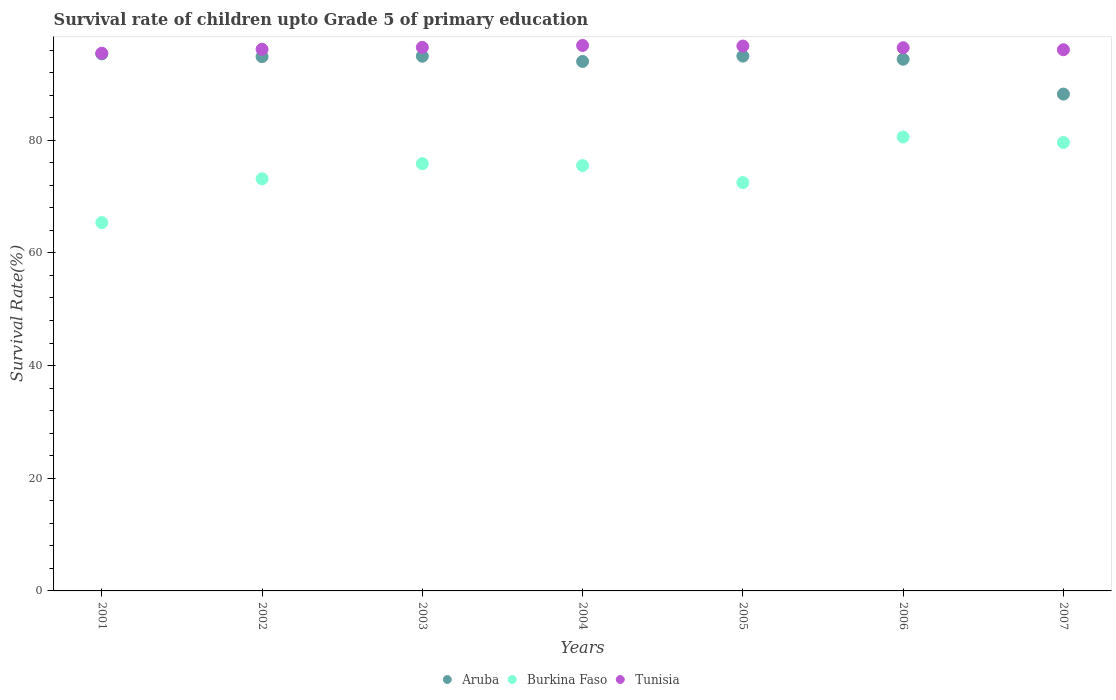How many different coloured dotlines are there?
Your response must be concise. 3. What is the survival rate of children in Aruba in 2005?
Offer a terse response. 94.94. Across all years, what is the maximum survival rate of children in Aruba?
Offer a terse response. 95.33. Across all years, what is the minimum survival rate of children in Aruba?
Make the answer very short. 88.2. What is the total survival rate of children in Aruba in the graph?
Your answer should be very brief. 656.62. What is the difference between the survival rate of children in Aruba in 2002 and that in 2005?
Provide a short and direct response. -0.09. What is the difference between the survival rate of children in Burkina Faso in 2006 and the survival rate of children in Tunisia in 2004?
Make the answer very short. -16.26. What is the average survival rate of children in Burkina Faso per year?
Keep it short and to the point. 74.66. In the year 2003, what is the difference between the survival rate of children in Aruba and survival rate of children in Tunisia?
Your response must be concise. -1.57. In how many years, is the survival rate of children in Tunisia greater than 72 %?
Provide a short and direct response. 7. What is the ratio of the survival rate of children in Tunisia in 2001 to that in 2002?
Provide a succinct answer. 0.99. Is the survival rate of children in Burkina Faso in 2001 less than that in 2007?
Keep it short and to the point. Yes. Is the difference between the survival rate of children in Aruba in 2001 and 2007 greater than the difference between the survival rate of children in Tunisia in 2001 and 2007?
Offer a very short reply. Yes. What is the difference between the highest and the second highest survival rate of children in Tunisia?
Your answer should be compact. 0.11. What is the difference between the highest and the lowest survival rate of children in Aruba?
Make the answer very short. 7.13. In how many years, is the survival rate of children in Burkina Faso greater than the average survival rate of children in Burkina Faso taken over all years?
Provide a short and direct response. 4. Is it the case that in every year, the sum of the survival rate of children in Burkina Faso and survival rate of children in Aruba  is greater than the survival rate of children in Tunisia?
Offer a very short reply. Yes. Is the survival rate of children in Burkina Faso strictly greater than the survival rate of children in Aruba over the years?
Keep it short and to the point. No. How many years are there in the graph?
Offer a very short reply. 7. Are the values on the major ticks of Y-axis written in scientific E-notation?
Ensure brevity in your answer.  No. Does the graph contain any zero values?
Give a very brief answer. No. Does the graph contain grids?
Your response must be concise. No. Where does the legend appear in the graph?
Ensure brevity in your answer.  Bottom center. How many legend labels are there?
Your answer should be very brief. 3. How are the legend labels stacked?
Provide a succinct answer. Horizontal. What is the title of the graph?
Your response must be concise. Survival rate of children upto Grade 5 of primary education. Does "Macao" appear as one of the legend labels in the graph?
Provide a short and direct response. No. What is the label or title of the X-axis?
Your answer should be very brief. Years. What is the label or title of the Y-axis?
Your response must be concise. Survival Rate(%). What is the Survival Rate(%) of Aruba in 2001?
Offer a terse response. 95.33. What is the Survival Rate(%) of Burkina Faso in 2001?
Provide a succinct answer. 65.39. What is the Survival Rate(%) in Tunisia in 2001?
Make the answer very short. 95.46. What is the Survival Rate(%) of Aruba in 2002?
Your answer should be very brief. 94.85. What is the Survival Rate(%) in Burkina Faso in 2002?
Your response must be concise. 73.16. What is the Survival Rate(%) in Tunisia in 2002?
Offer a terse response. 96.15. What is the Survival Rate(%) in Aruba in 2003?
Your answer should be compact. 94.92. What is the Survival Rate(%) of Burkina Faso in 2003?
Provide a short and direct response. 75.85. What is the Survival Rate(%) of Tunisia in 2003?
Give a very brief answer. 96.49. What is the Survival Rate(%) in Aruba in 2004?
Offer a very short reply. 94. What is the Survival Rate(%) in Burkina Faso in 2004?
Give a very brief answer. 75.51. What is the Survival Rate(%) in Tunisia in 2004?
Make the answer very short. 96.84. What is the Survival Rate(%) of Aruba in 2005?
Your answer should be very brief. 94.94. What is the Survival Rate(%) of Burkina Faso in 2005?
Your answer should be compact. 72.49. What is the Survival Rate(%) in Tunisia in 2005?
Offer a terse response. 96.73. What is the Survival Rate(%) of Aruba in 2006?
Your answer should be very brief. 94.39. What is the Survival Rate(%) of Burkina Faso in 2006?
Offer a terse response. 80.58. What is the Survival Rate(%) of Tunisia in 2006?
Provide a succinct answer. 96.43. What is the Survival Rate(%) of Aruba in 2007?
Provide a short and direct response. 88.2. What is the Survival Rate(%) in Burkina Faso in 2007?
Your answer should be very brief. 79.61. What is the Survival Rate(%) in Tunisia in 2007?
Offer a very short reply. 96.08. Across all years, what is the maximum Survival Rate(%) in Aruba?
Your response must be concise. 95.33. Across all years, what is the maximum Survival Rate(%) of Burkina Faso?
Your answer should be very brief. 80.58. Across all years, what is the maximum Survival Rate(%) of Tunisia?
Make the answer very short. 96.84. Across all years, what is the minimum Survival Rate(%) of Aruba?
Provide a succinct answer. 88.2. Across all years, what is the minimum Survival Rate(%) of Burkina Faso?
Your answer should be very brief. 65.39. Across all years, what is the minimum Survival Rate(%) in Tunisia?
Provide a short and direct response. 95.46. What is the total Survival Rate(%) of Aruba in the graph?
Keep it short and to the point. 656.62. What is the total Survival Rate(%) of Burkina Faso in the graph?
Provide a short and direct response. 522.59. What is the total Survival Rate(%) of Tunisia in the graph?
Ensure brevity in your answer.  674.17. What is the difference between the Survival Rate(%) of Aruba in 2001 and that in 2002?
Offer a terse response. 0.49. What is the difference between the Survival Rate(%) of Burkina Faso in 2001 and that in 2002?
Your answer should be compact. -7.77. What is the difference between the Survival Rate(%) of Tunisia in 2001 and that in 2002?
Your answer should be very brief. -0.7. What is the difference between the Survival Rate(%) in Aruba in 2001 and that in 2003?
Your response must be concise. 0.41. What is the difference between the Survival Rate(%) of Burkina Faso in 2001 and that in 2003?
Offer a terse response. -10.47. What is the difference between the Survival Rate(%) in Tunisia in 2001 and that in 2003?
Offer a very short reply. -1.04. What is the difference between the Survival Rate(%) in Aruba in 2001 and that in 2004?
Make the answer very short. 1.34. What is the difference between the Survival Rate(%) of Burkina Faso in 2001 and that in 2004?
Your response must be concise. -10.12. What is the difference between the Survival Rate(%) of Tunisia in 2001 and that in 2004?
Your response must be concise. -1.38. What is the difference between the Survival Rate(%) in Aruba in 2001 and that in 2005?
Make the answer very short. 0.39. What is the difference between the Survival Rate(%) in Burkina Faso in 2001 and that in 2005?
Keep it short and to the point. -7.1. What is the difference between the Survival Rate(%) of Tunisia in 2001 and that in 2005?
Offer a terse response. -1.27. What is the difference between the Survival Rate(%) of Aruba in 2001 and that in 2006?
Make the answer very short. 0.95. What is the difference between the Survival Rate(%) of Burkina Faso in 2001 and that in 2006?
Provide a short and direct response. -15.19. What is the difference between the Survival Rate(%) of Tunisia in 2001 and that in 2006?
Keep it short and to the point. -0.97. What is the difference between the Survival Rate(%) in Aruba in 2001 and that in 2007?
Ensure brevity in your answer.  7.13. What is the difference between the Survival Rate(%) of Burkina Faso in 2001 and that in 2007?
Keep it short and to the point. -14.22. What is the difference between the Survival Rate(%) in Tunisia in 2001 and that in 2007?
Your answer should be compact. -0.62. What is the difference between the Survival Rate(%) in Aruba in 2002 and that in 2003?
Offer a terse response. -0.07. What is the difference between the Survival Rate(%) in Burkina Faso in 2002 and that in 2003?
Your answer should be compact. -2.69. What is the difference between the Survival Rate(%) of Tunisia in 2002 and that in 2003?
Provide a short and direct response. -0.34. What is the difference between the Survival Rate(%) in Aruba in 2002 and that in 2004?
Your answer should be very brief. 0.85. What is the difference between the Survival Rate(%) of Burkina Faso in 2002 and that in 2004?
Give a very brief answer. -2.35. What is the difference between the Survival Rate(%) of Tunisia in 2002 and that in 2004?
Provide a short and direct response. -0.68. What is the difference between the Survival Rate(%) of Aruba in 2002 and that in 2005?
Provide a short and direct response. -0.09. What is the difference between the Survival Rate(%) of Burkina Faso in 2002 and that in 2005?
Keep it short and to the point. 0.67. What is the difference between the Survival Rate(%) in Tunisia in 2002 and that in 2005?
Give a very brief answer. -0.58. What is the difference between the Survival Rate(%) of Aruba in 2002 and that in 2006?
Make the answer very short. 0.46. What is the difference between the Survival Rate(%) of Burkina Faso in 2002 and that in 2006?
Provide a short and direct response. -7.42. What is the difference between the Survival Rate(%) of Tunisia in 2002 and that in 2006?
Offer a very short reply. -0.27. What is the difference between the Survival Rate(%) in Aruba in 2002 and that in 2007?
Offer a very short reply. 6.65. What is the difference between the Survival Rate(%) in Burkina Faso in 2002 and that in 2007?
Ensure brevity in your answer.  -6.45. What is the difference between the Survival Rate(%) in Tunisia in 2002 and that in 2007?
Give a very brief answer. 0.08. What is the difference between the Survival Rate(%) of Aruba in 2003 and that in 2004?
Provide a succinct answer. 0.92. What is the difference between the Survival Rate(%) of Burkina Faso in 2003 and that in 2004?
Give a very brief answer. 0.34. What is the difference between the Survival Rate(%) in Tunisia in 2003 and that in 2004?
Provide a short and direct response. -0.34. What is the difference between the Survival Rate(%) of Aruba in 2003 and that in 2005?
Offer a very short reply. -0.02. What is the difference between the Survival Rate(%) of Burkina Faso in 2003 and that in 2005?
Ensure brevity in your answer.  3.36. What is the difference between the Survival Rate(%) of Tunisia in 2003 and that in 2005?
Provide a succinct answer. -0.23. What is the difference between the Survival Rate(%) of Aruba in 2003 and that in 2006?
Your answer should be very brief. 0.53. What is the difference between the Survival Rate(%) of Burkina Faso in 2003 and that in 2006?
Offer a very short reply. -4.72. What is the difference between the Survival Rate(%) of Tunisia in 2003 and that in 2006?
Give a very brief answer. 0.07. What is the difference between the Survival Rate(%) of Aruba in 2003 and that in 2007?
Provide a short and direct response. 6.72. What is the difference between the Survival Rate(%) in Burkina Faso in 2003 and that in 2007?
Keep it short and to the point. -3.76. What is the difference between the Survival Rate(%) of Tunisia in 2003 and that in 2007?
Your response must be concise. 0.42. What is the difference between the Survival Rate(%) of Aruba in 2004 and that in 2005?
Provide a succinct answer. -0.94. What is the difference between the Survival Rate(%) in Burkina Faso in 2004 and that in 2005?
Keep it short and to the point. 3.02. What is the difference between the Survival Rate(%) in Tunisia in 2004 and that in 2005?
Your response must be concise. 0.11. What is the difference between the Survival Rate(%) of Aruba in 2004 and that in 2006?
Your answer should be very brief. -0.39. What is the difference between the Survival Rate(%) in Burkina Faso in 2004 and that in 2006?
Offer a very short reply. -5.07. What is the difference between the Survival Rate(%) of Tunisia in 2004 and that in 2006?
Make the answer very short. 0.41. What is the difference between the Survival Rate(%) in Aruba in 2004 and that in 2007?
Keep it short and to the point. 5.8. What is the difference between the Survival Rate(%) in Burkina Faso in 2004 and that in 2007?
Your answer should be very brief. -4.1. What is the difference between the Survival Rate(%) in Tunisia in 2004 and that in 2007?
Give a very brief answer. 0.76. What is the difference between the Survival Rate(%) in Aruba in 2005 and that in 2006?
Your answer should be very brief. 0.55. What is the difference between the Survival Rate(%) in Burkina Faso in 2005 and that in 2006?
Your response must be concise. -8.09. What is the difference between the Survival Rate(%) in Tunisia in 2005 and that in 2006?
Keep it short and to the point. 0.3. What is the difference between the Survival Rate(%) of Aruba in 2005 and that in 2007?
Ensure brevity in your answer.  6.74. What is the difference between the Survival Rate(%) of Burkina Faso in 2005 and that in 2007?
Provide a succinct answer. -7.12. What is the difference between the Survival Rate(%) in Tunisia in 2005 and that in 2007?
Your answer should be compact. 0.65. What is the difference between the Survival Rate(%) of Aruba in 2006 and that in 2007?
Offer a terse response. 6.19. What is the difference between the Survival Rate(%) of Tunisia in 2006 and that in 2007?
Your answer should be very brief. 0.35. What is the difference between the Survival Rate(%) in Aruba in 2001 and the Survival Rate(%) in Burkina Faso in 2002?
Offer a terse response. 22.17. What is the difference between the Survival Rate(%) of Aruba in 2001 and the Survival Rate(%) of Tunisia in 2002?
Your answer should be compact. -0.82. What is the difference between the Survival Rate(%) in Burkina Faso in 2001 and the Survival Rate(%) in Tunisia in 2002?
Provide a succinct answer. -30.77. What is the difference between the Survival Rate(%) in Aruba in 2001 and the Survival Rate(%) in Burkina Faso in 2003?
Your answer should be compact. 19.48. What is the difference between the Survival Rate(%) of Aruba in 2001 and the Survival Rate(%) of Tunisia in 2003?
Offer a terse response. -1.16. What is the difference between the Survival Rate(%) of Burkina Faso in 2001 and the Survival Rate(%) of Tunisia in 2003?
Provide a succinct answer. -31.11. What is the difference between the Survival Rate(%) of Aruba in 2001 and the Survival Rate(%) of Burkina Faso in 2004?
Give a very brief answer. 19.82. What is the difference between the Survival Rate(%) in Aruba in 2001 and the Survival Rate(%) in Tunisia in 2004?
Ensure brevity in your answer.  -1.5. What is the difference between the Survival Rate(%) of Burkina Faso in 2001 and the Survival Rate(%) of Tunisia in 2004?
Your answer should be very brief. -31.45. What is the difference between the Survival Rate(%) in Aruba in 2001 and the Survival Rate(%) in Burkina Faso in 2005?
Your answer should be very brief. 22.84. What is the difference between the Survival Rate(%) in Aruba in 2001 and the Survival Rate(%) in Tunisia in 2005?
Ensure brevity in your answer.  -1.4. What is the difference between the Survival Rate(%) in Burkina Faso in 2001 and the Survival Rate(%) in Tunisia in 2005?
Your response must be concise. -31.34. What is the difference between the Survival Rate(%) in Aruba in 2001 and the Survival Rate(%) in Burkina Faso in 2006?
Make the answer very short. 14.75. What is the difference between the Survival Rate(%) of Aruba in 2001 and the Survival Rate(%) of Tunisia in 2006?
Your answer should be compact. -1.09. What is the difference between the Survival Rate(%) of Burkina Faso in 2001 and the Survival Rate(%) of Tunisia in 2006?
Provide a succinct answer. -31.04. What is the difference between the Survival Rate(%) of Aruba in 2001 and the Survival Rate(%) of Burkina Faso in 2007?
Make the answer very short. 15.72. What is the difference between the Survival Rate(%) of Aruba in 2001 and the Survival Rate(%) of Tunisia in 2007?
Provide a short and direct response. -0.74. What is the difference between the Survival Rate(%) of Burkina Faso in 2001 and the Survival Rate(%) of Tunisia in 2007?
Provide a succinct answer. -30.69. What is the difference between the Survival Rate(%) in Aruba in 2002 and the Survival Rate(%) in Burkina Faso in 2003?
Your answer should be compact. 18.99. What is the difference between the Survival Rate(%) of Aruba in 2002 and the Survival Rate(%) of Tunisia in 2003?
Give a very brief answer. -1.65. What is the difference between the Survival Rate(%) of Burkina Faso in 2002 and the Survival Rate(%) of Tunisia in 2003?
Your answer should be compact. -23.34. What is the difference between the Survival Rate(%) in Aruba in 2002 and the Survival Rate(%) in Burkina Faso in 2004?
Your response must be concise. 19.33. What is the difference between the Survival Rate(%) in Aruba in 2002 and the Survival Rate(%) in Tunisia in 2004?
Offer a terse response. -1.99. What is the difference between the Survival Rate(%) of Burkina Faso in 2002 and the Survival Rate(%) of Tunisia in 2004?
Offer a very short reply. -23.68. What is the difference between the Survival Rate(%) of Aruba in 2002 and the Survival Rate(%) of Burkina Faso in 2005?
Keep it short and to the point. 22.36. What is the difference between the Survival Rate(%) in Aruba in 2002 and the Survival Rate(%) in Tunisia in 2005?
Your response must be concise. -1.88. What is the difference between the Survival Rate(%) of Burkina Faso in 2002 and the Survival Rate(%) of Tunisia in 2005?
Give a very brief answer. -23.57. What is the difference between the Survival Rate(%) of Aruba in 2002 and the Survival Rate(%) of Burkina Faso in 2006?
Provide a succinct answer. 14.27. What is the difference between the Survival Rate(%) in Aruba in 2002 and the Survival Rate(%) in Tunisia in 2006?
Give a very brief answer. -1.58. What is the difference between the Survival Rate(%) of Burkina Faso in 2002 and the Survival Rate(%) of Tunisia in 2006?
Ensure brevity in your answer.  -23.27. What is the difference between the Survival Rate(%) in Aruba in 2002 and the Survival Rate(%) in Burkina Faso in 2007?
Offer a terse response. 15.24. What is the difference between the Survival Rate(%) in Aruba in 2002 and the Survival Rate(%) in Tunisia in 2007?
Offer a terse response. -1.23. What is the difference between the Survival Rate(%) of Burkina Faso in 2002 and the Survival Rate(%) of Tunisia in 2007?
Give a very brief answer. -22.92. What is the difference between the Survival Rate(%) of Aruba in 2003 and the Survival Rate(%) of Burkina Faso in 2004?
Your answer should be compact. 19.41. What is the difference between the Survival Rate(%) of Aruba in 2003 and the Survival Rate(%) of Tunisia in 2004?
Provide a short and direct response. -1.92. What is the difference between the Survival Rate(%) of Burkina Faso in 2003 and the Survival Rate(%) of Tunisia in 2004?
Provide a short and direct response. -20.98. What is the difference between the Survival Rate(%) in Aruba in 2003 and the Survival Rate(%) in Burkina Faso in 2005?
Your answer should be compact. 22.43. What is the difference between the Survival Rate(%) in Aruba in 2003 and the Survival Rate(%) in Tunisia in 2005?
Offer a terse response. -1.81. What is the difference between the Survival Rate(%) of Burkina Faso in 2003 and the Survival Rate(%) of Tunisia in 2005?
Offer a very short reply. -20.88. What is the difference between the Survival Rate(%) of Aruba in 2003 and the Survival Rate(%) of Burkina Faso in 2006?
Keep it short and to the point. 14.34. What is the difference between the Survival Rate(%) of Aruba in 2003 and the Survival Rate(%) of Tunisia in 2006?
Offer a terse response. -1.51. What is the difference between the Survival Rate(%) in Burkina Faso in 2003 and the Survival Rate(%) in Tunisia in 2006?
Your answer should be compact. -20.57. What is the difference between the Survival Rate(%) of Aruba in 2003 and the Survival Rate(%) of Burkina Faso in 2007?
Your answer should be compact. 15.31. What is the difference between the Survival Rate(%) of Aruba in 2003 and the Survival Rate(%) of Tunisia in 2007?
Keep it short and to the point. -1.15. What is the difference between the Survival Rate(%) in Burkina Faso in 2003 and the Survival Rate(%) in Tunisia in 2007?
Keep it short and to the point. -20.22. What is the difference between the Survival Rate(%) of Aruba in 2004 and the Survival Rate(%) of Burkina Faso in 2005?
Ensure brevity in your answer.  21.51. What is the difference between the Survival Rate(%) in Aruba in 2004 and the Survival Rate(%) in Tunisia in 2005?
Offer a very short reply. -2.73. What is the difference between the Survival Rate(%) of Burkina Faso in 2004 and the Survival Rate(%) of Tunisia in 2005?
Your answer should be compact. -21.22. What is the difference between the Survival Rate(%) of Aruba in 2004 and the Survival Rate(%) of Burkina Faso in 2006?
Provide a succinct answer. 13.42. What is the difference between the Survival Rate(%) of Aruba in 2004 and the Survival Rate(%) of Tunisia in 2006?
Offer a terse response. -2.43. What is the difference between the Survival Rate(%) in Burkina Faso in 2004 and the Survival Rate(%) in Tunisia in 2006?
Offer a terse response. -20.91. What is the difference between the Survival Rate(%) in Aruba in 2004 and the Survival Rate(%) in Burkina Faso in 2007?
Offer a terse response. 14.39. What is the difference between the Survival Rate(%) in Aruba in 2004 and the Survival Rate(%) in Tunisia in 2007?
Your answer should be compact. -2.08. What is the difference between the Survival Rate(%) of Burkina Faso in 2004 and the Survival Rate(%) of Tunisia in 2007?
Offer a very short reply. -20.56. What is the difference between the Survival Rate(%) of Aruba in 2005 and the Survival Rate(%) of Burkina Faso in 2006?
Provide a succinct answer. 14.36. What is the difference between the Survival Rate(%) of Aruba in 2005 and the Survival Rate(%) of Tunisia in 2006?
Your response must be concise. -1.49. What is the difference between the Survival Rate(%) in Burkina Faso in 2005 and the Survival Rate(%) in Tunisia in 2006?
Offer a terse response. -23.94. What is the difference between the Survival Rate(%) of Aruba in 2005 and the Survival Rate(%) of Burkina Faso in 2007?
Provide a succinct answer. 15.33. What is the difference between the Survival Rate(%) of Aruba in 2005 and the Survival Rate(%) of Tunisia in 2007?
Your answer should be very brief. -1.14. What is the difference between the Survival Rate(%) of Burkina Faso in 2005 and the Survival Rate(%) of Tunisia in 2007?
Keep it short and to the point. -23.59. What is the difference between the Survival Rate(%) of Aruba in 2006 and the Survival Rate(%) of Burkina Faso in 2007?
Offer a very short reply. 14.77. What is the difference between the Survival Rate(%) of Aruba in 2006 and the Survival Rate(%) of Tunisia in 2007?
Make the answer very short. -1.69. What is the difference between the Survival Rate(%) in Burkina Faso in 2006 and the Survival Rate(%) in Tunisia in 2007?
Offer a very short reply. -15.5. What is the average Survival Rate(%) in Aruba per year?
Make the answer very short. 93.8. What is the average Survival Rate(%) of Burkina Faso per year?
Your answer should be very brief. 74.66. What is the average Survival Rate(%) of Tunisia per year?
Your response must be concise. 96.31. In the year 2001, what is the difference between the Survival Rate(%) of Aruba and Survival Rate(%) of Burkina Faso?
Keep it short and to the point. 29.94. In the year 2001, what is the difference between the Survival Rate(%) in Aruba and Survival Rate(%) in Tunisia?
Your answer should be very brief. -0.12. In the year 2001, what is the difference between the Survival Rate(%) in Burkina Faso and Survival Rate(%) in Tunisia?
Provide a succinct answer. -30.07. In the year 2002, what is the difference between the Survival Rate(%) in Aruba and Survival Rate(%) in Burkina Faso?
Provide a succinct answer. 21.69. In the year 2002, what is the difference between the Survival Rate(%) in Aruba and Survival Rate(%) in Tunisia?
Your response must be concise. -1.31. In the year 2002, what is the difference between the Survival Rate(%) in Burkina Faso and Survival Rate(%) in Tunisia?
Offer a very short reply. -22.99. In the year 2003, what is the difference between the Survival Rate(%) of Aruba and Survival Rate(%) of Burkina Faso?
Ensure brevity in your answer.  19.07. In the year 2003, what is the difference between the Survival Rate(%) of Aruba and Survival Rate(%) of Tunisia?
Offer a terse response. -1.57. In the year 2003, what is the difference between the Survival Rate(%) of Burkina Faso and Survival Rate(%) of Tunisia?
Offer a terse response. -20.64. In the year 2004, what is the difference between the Survival Rate(%) in Aruba and Survival Rate(%) in Burkina Faso?
Ensure brevity in your answer.  18.48. In the year 2004, what is the difference between the Survival Rate(%) of Aruba and Survival Rate(%) of Tunisia?
Offer a terse response. -2.84. In the year 2004, what is the difference between the Survival Rate(%) of Burkina Faso and Survival Rate(%) of Tunisia?
Give a very brief answer. -21.32. In the year 2005, what is the difference between the Survival Rate(%) of Aruba and Survival Rate(%) of Burkina Faso?
Your answer should be very brief. 22.45. In the year 2005, what is the difference between the Survival Rate(%) of Aruba and Survival Rate(%) of Tunisia?
Your response must be concise. -1.79. In the year 2005, what is the difference between the Survival Rate(%) in Burkina Faso and Survival Rate(%) in Tunisia?
Your answer should be very brief. -24.24. In the year 2006, what is the difference between the Survival Rate(%) of Aruba and Survival Rate(%) of Burkina Faso?
Ensure brevity in your answer.  13.81. In the year 2006, what is the difference between the Survival Rate(%) of Aruba and Survival Rate(%) of Tunisia?
Offer a terse response. -2.04. In the year 2006, what is the difference between the Survival Rate(%) in Burkina Faso and Survival Rate(%) in Tunisia?
Make the answer very short. -15.85. In the year 2007, what is the difference between the Survival Rate(%) in Aruba and Survival Rate(%) in Burkina Faso?
Your answer should be compact. 8.59. In the year 2007, what is the difference between the Survival Rate(%) in Aruba and Survival Rate(%) in Tunisia?
Make the answer very short. -7.88. In the year 2007, what is the difference between the Survival Rate(%) in Burkina Faso and Survival Rate(%) in Tunisia?
Provide a short and direct response. -16.46. What is the ratio of the Survival Rate(%) of Aruba in 2001 to that in 2002?
Offer a terse response. 1.01. What is the ratio of the Survival Rate(%) of Burkina Faso in 2001 to that in 2002?
Your answer should be very brief. 0.89. What is the ratio of the Survival Rate(%) in Burkina Faso in 2001 to that in 2003?
Your response must be concise. 0.86. What is the ratio of the Survival Rate(%) in Aruba in 2001 to that in 2004?
Keep it short and to the point. 1.01. What is the ratio of the Survival Rate(%) in Burkina Faso in 2001 to that in 2004?
Your answer should be compact. 0.87. What is the ratio of the Survival Rate(%) of Tunisia in 2001 to that in 2004?
Keep it short and to the point. 0.99. What is the ratio of the Survival Rate(%) in Aruba in 2001 to that in 2005?
Ensure brevity in your answer.  1. What is the ratio of the Survival Rate(%) in Burkina Faso in 2001 to that in 2005?
Make the answer very short. 0.9. What is the ratio of the Survival Rate(%) of Burkina Faso in 2001 to that in 2006?
Make the answer very short. 0.81. What is the ratio of the Survival Rate(%) of Aruba in 2001 to that in 2007?
Offer a very short reply. 1.08. What is the ratio of the Survival Rate(%) in Burkina Faso in 2001 to that in 2007?
Offer a very short reply. 0.82. What is the ratio of the Survival Rate(%) in Aruba in 2002 to that in 2003?
Provide a succinct answer. 1. What is the ratio of the Survival Rate(%) in Burkina Faso in 2002 to that in 2003?
Offer a terse response. 0.96. What is the ratio of the Survival Rate(%) of Tunisia in 2002 to that in 2003?
Give a very brief answer. 1. What is the ratio of the Survival Rate(%) of Burkina Faso in 2002 to that in 2004?
Make the answer very short. 0.97. What is the ratio of the Survival Rate(%) of Tunisia in 2002 to that in 2004?
Offer a very short reply. 0.99. What is the ratio of the Survival Rate(%) of Burkina Faso in 2002 to that in 2005?
Offer a very short reply. 1.01. What is the ratio of the Survival Rate(%) of Aruba in 2002 to that in 2006?
Offer a terse response. 1. What is the ratio of the Survival Rate(%) of Burkina Faso in 2002 to that in 2006?
Your answer should be very brief. 0.91. What is the ratio of the Survival Rate(%) of Tunisia in 2002 to that in 2006?
Provide a short and direct response. 1. What is the ratio of the Survival Rate(%) of Aruba in 2002 to that in 2007?
Make the answer very short. 1.08. What is the ratio of the Survival Rate(%) in Burkina Faso in 2002 to that in 2007?
Provide a succinct answer. 0.92. What is the ratio of the Survival Rate(%) in Tunisia in 2002 to that in 2007?
Provide a succinct answer. 1. What is the ratio of the Survival Rate(%) in Aruba in 2003 to that in 2004?
Keep it short and to the point. 1.01. What is the ratio of the Survival Rate(%) of Burkina Faso in 2003 to that in 2004?
Offer a terse response. 1. What is the ratio of the Survival Rate(%) of Burkina Faso in 2003 to that in 2005?
Keep it short and to the point. 1.05. What is the ratio of the Survival Rate(%) of Tunisia in 2003 to that in 2005?
Your answer should be compact. 1. What is the ratio of the Survival Rate(%) of Aruba in 2003 to that in 2006?
Give a very brief answer. 1.01. What is the ratio of the Survival Rate(%) in Burkina Faso in 2003 to that in 2006?
Give a very brief answer. 0.94. What is the ratio of the Survival Rate(%) in Aruba in 2003 to that in 2007?
Provide a short and direct response. 1.08. What is the ratio of the Survival Rate(%) of Burkina Faso in 2003 to that in 2007?
Your response must be concise. 0.95. What is the ratio of the Survival Rate(%) of Burkina Faso in 2004 to that in 2005?
Your response must be concise. 1.04. What is the ratio of the Survival Rate(%) in Burkina Faso in 2004 to that in 2006?
Ensure brevity in your answer.  0.94. What is the ratio of the Survival Rate(%) in Tunisia in 2004 to that in 2006?
Ensure brevity in your answer.  1. What is the ratio of the Survival Rate(%) of Aruba in 2004 to that in 2007?
Provide a succinct answer. 1.07. What is the ratio of the Survival Rate(%) in Burkina Faso in 2004 to that in 2007?
Your response must be concise. 0.95. What is the ratio of the Survival Rate(%) of Tunisia in 2004 to that in 2007?
Offer a terse response. 1.01. What is the ratio of the Survival Rate(%) of Aruba in 2005 to that in 2006?
Your answer should be very brief. 1.01. What is the ratio of the Survival Rate(%) of Burkina Faso in 2005 to that in 2006?
Keep it short and to the point. 0.9. What is the ratio of the Survival Rate(%) of Tunisia in 2005 to that in 2006?
Ensure brevity in your answer.  1. What is the ratio of the Survival Rate(%) in Aruba in 2005 to that in 2007?
Offer a very short reply. 1.08. What is the ratio of the Survival Rate(%) of Burkina Faso in 2005 to that in 2007?
Offer a terse response. 0.91. What is the ratio of the Survival Rate(%) in Tunisia in 2005 to that in 2007?
Give a very brief answer. 1.01. What is the ratio of the Survival Rate(%) of Aruba in 2006 to that in 2007?
Offer a very short reply. 1.07. What is the ratio of the Survival Rate(%) in Burkina Faso in 2006 to that in 2007?
Provide a succinct answer. 1.01. What is the difference between the highest and the second highest Survival Rate(%) in Aruba?
Ensure brevity in your answer.  0.39. What is the difference between the highest and the second highest Survival Rate(%) of Burkina Faso?
Give a very brief answer. 0.97. What is the difference between the highest and the second highest Survival Rate(%) of Tunisia?
Provide a succinct answer. 0.11. What is the difference between the highest and the lowest Survival Rate(%) in Aruba?
Offer a very short reply. 7.13. What is the difference between the highest and the lowest Survival Rate(%) in Burkina Faso?
Provide a short and direct response. 15.19. What is the difference between the highest and the lowest Survival Rate(%) of Tunisia?
Your response must be concise. 1.38. 